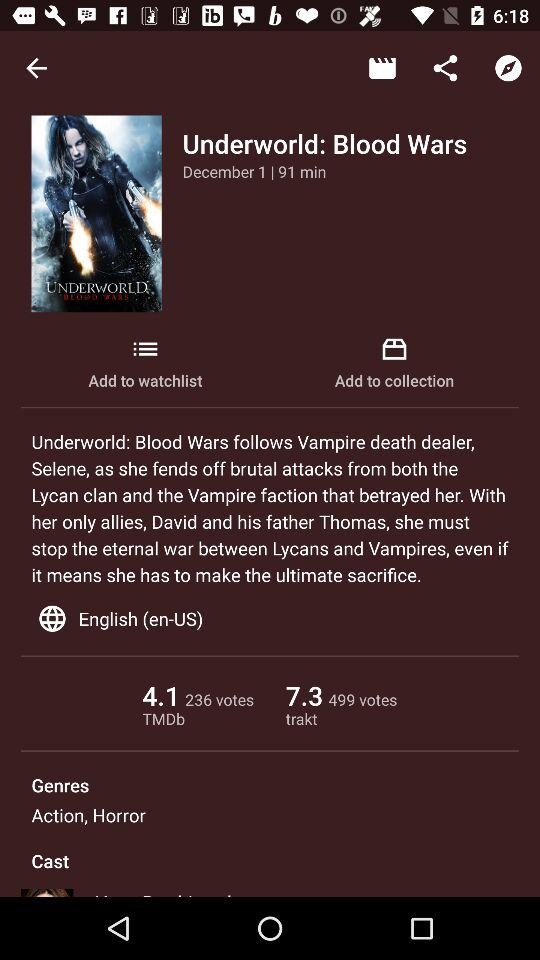What is the trakt rating? The rating is 7.3. 